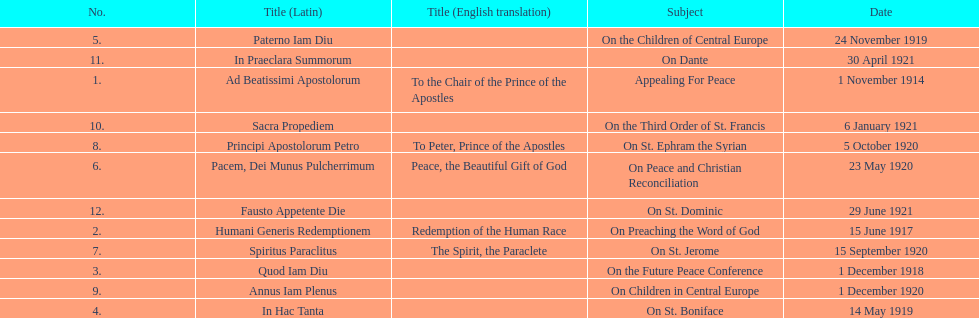How many titles are listed in the table? 12. 